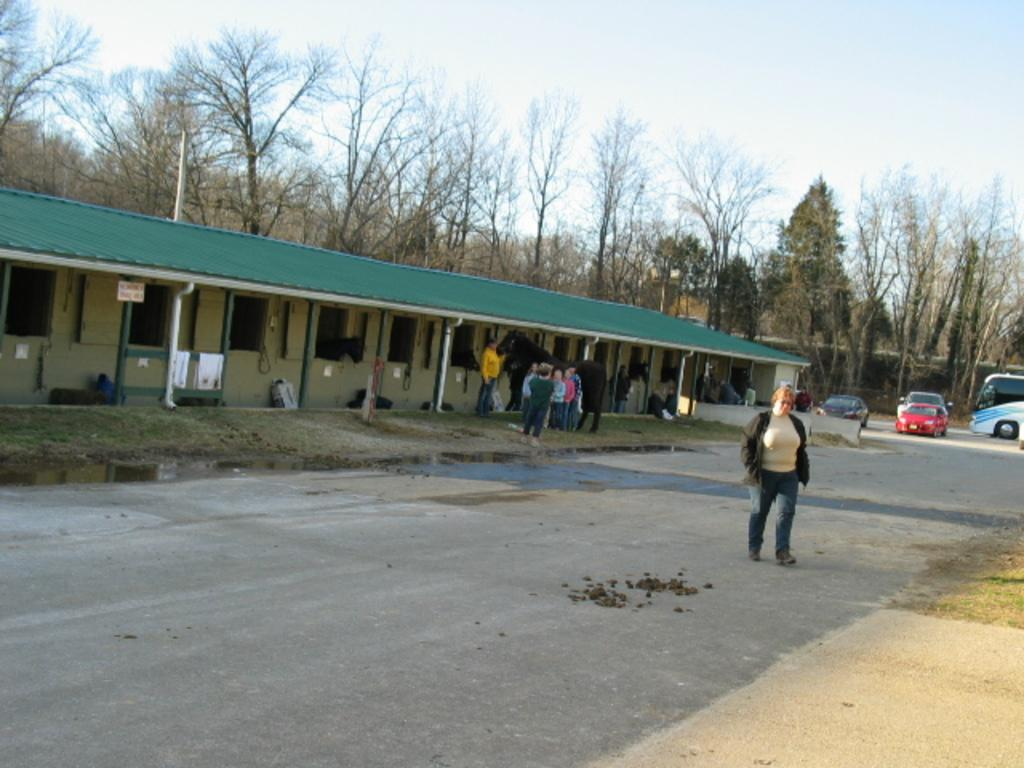What is the woman in the image doing? The woman is walking on the road in the image. What can be seen in the background of the image? There are persons, an animal, a shed, objects, poles, vehicles, trees, and the sky visible in the background of the image. What type of bean is being processed in the industry shown in the image? There is no industry or bean present in the image; it features a woman walking on the road and various elements in the background. How long does it take for the minute hand to move in the image? There is no clock or time-related element present in the image, so it is not possible to determine the movement of a minute hand. 